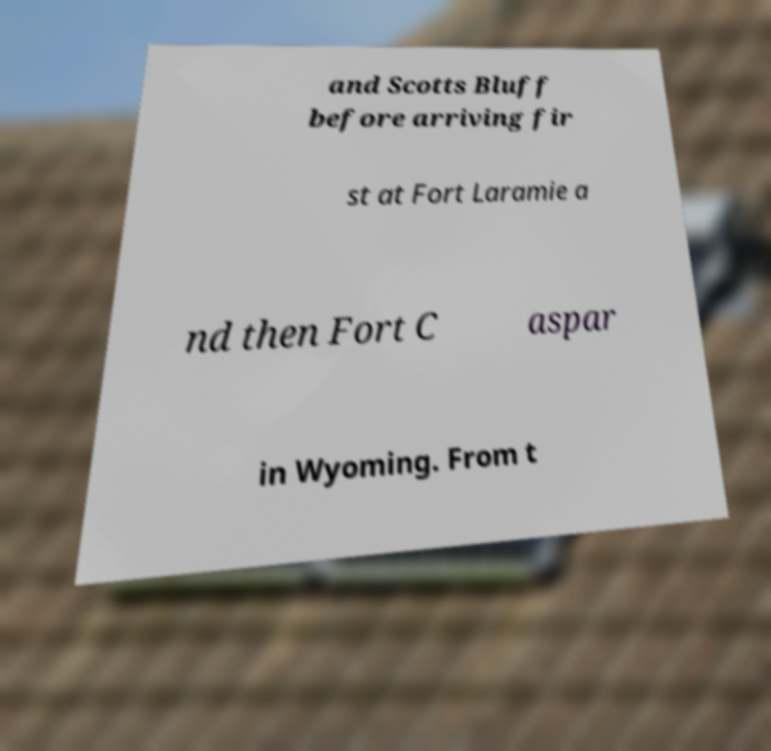Please identify and transcribe the text found in this image. and Scotts Bluff before arriving fir st at Fort Laramie a nd then Fort C aspar in Wyoming. From t 